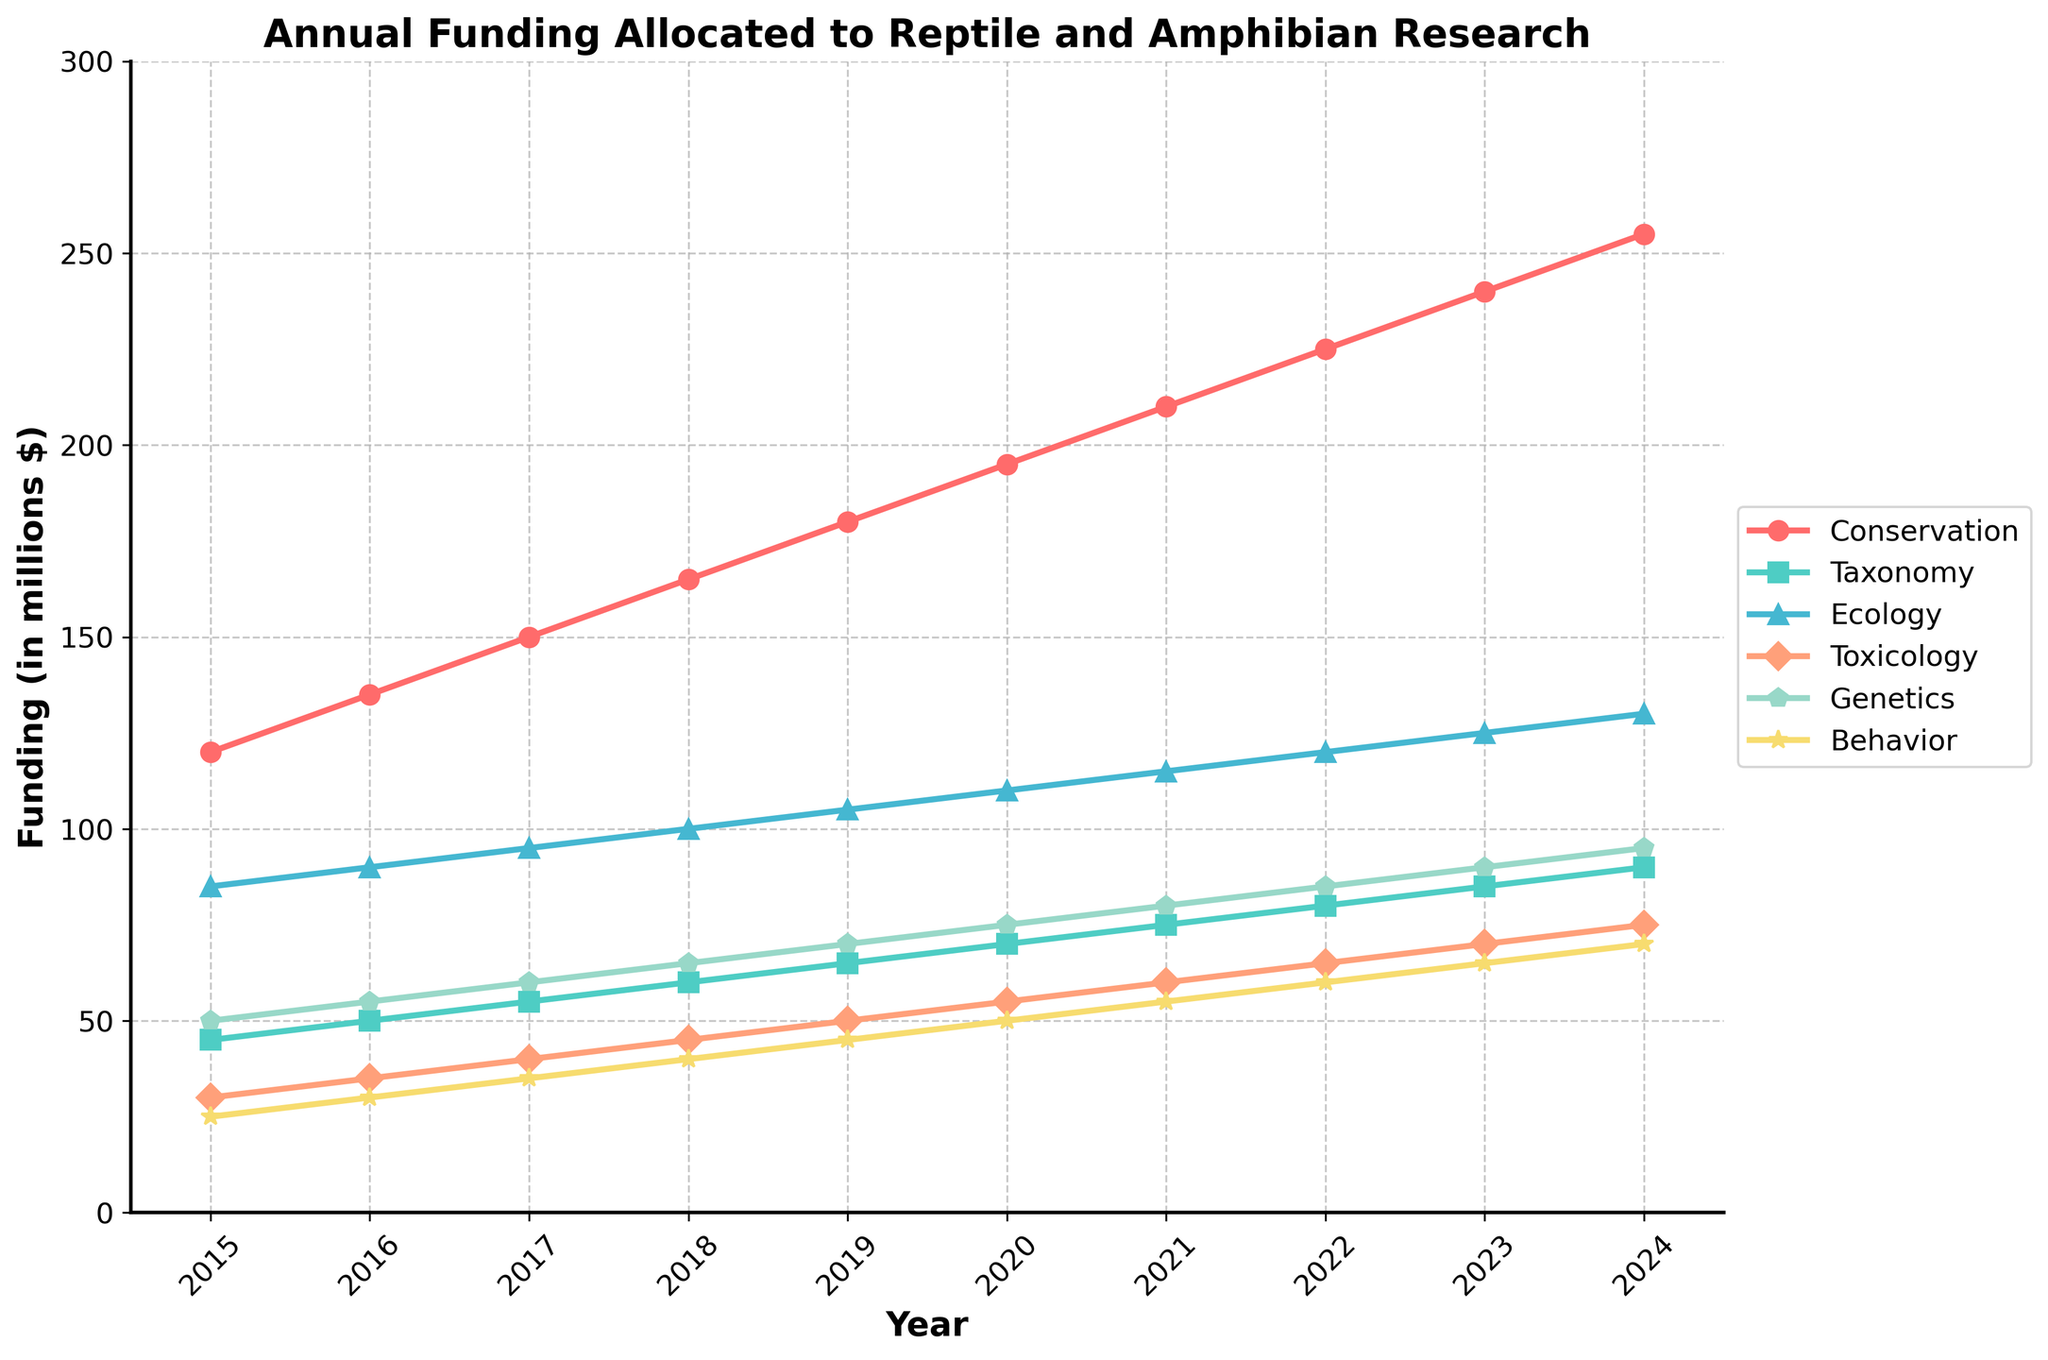What's the total funding allocated for Conservation and Ecology in 2017? First, identify the funding for Conservation and Ecology in 2017. Conservation funding is 150 and Ecology funding is 95. Summing these values gives 150 + 95 = 245.
Answer: 245 Which research focus received the highest funding in 2023? Assess the funding values for all research focuses in 2023. The highest value is for Conservation at 240.
Answer: Conservation Between which years did the funding for Genetics increase the most? Identify the year-to-year increases for Genetics. The largest increase is between 2023 (90) and 2024 (95), which is an increase of 5.
Answer: 2023-2024 What’s the average annual funding for Toxicology from 2015 to 2024? Sum the yearly funding for Toxicology and divide by the number of years: (30 + 35 + 40 + 45 + 50 + 55 + 60 + 65 + 70 + 75) / 10 = 52.5.
Answer: 52.5 In which year did Taxonomy and Behavior funding levels equal each other? Compare the funding data for each year. In 2018, Taxonomy and Behavior both have a funding of 60.
Answer: 2018 How much more funding did Conservation receive in 2024 compared to 2015? Subtract the Conservation funding in 2015 from that in 2024. Funding is 255 in 2024 and 120 in 2015. The difference is 255 - 120 = 135.
Answer: 135 Which focus saw the smallest increase in funding from 2015 to 2024? Calculate the increase for each focus from 2015 to 2024. Conservation (135), Taxonomy (45), Ecology (45), Toxicology (45), Genetics (45), Behavior (45). The smallest increase is for all except Conservation, which increased by 45.
Answer: Taxonomy, Ecology, Toxicology, Genetics, Behavior What’s the funding trend for Ecology over the years 2015 to 2024? Observe the trend line for Ecology. The funding increased steadily from 85 in 2015 to 130 in 2024.
Answer: Increasing steadily 